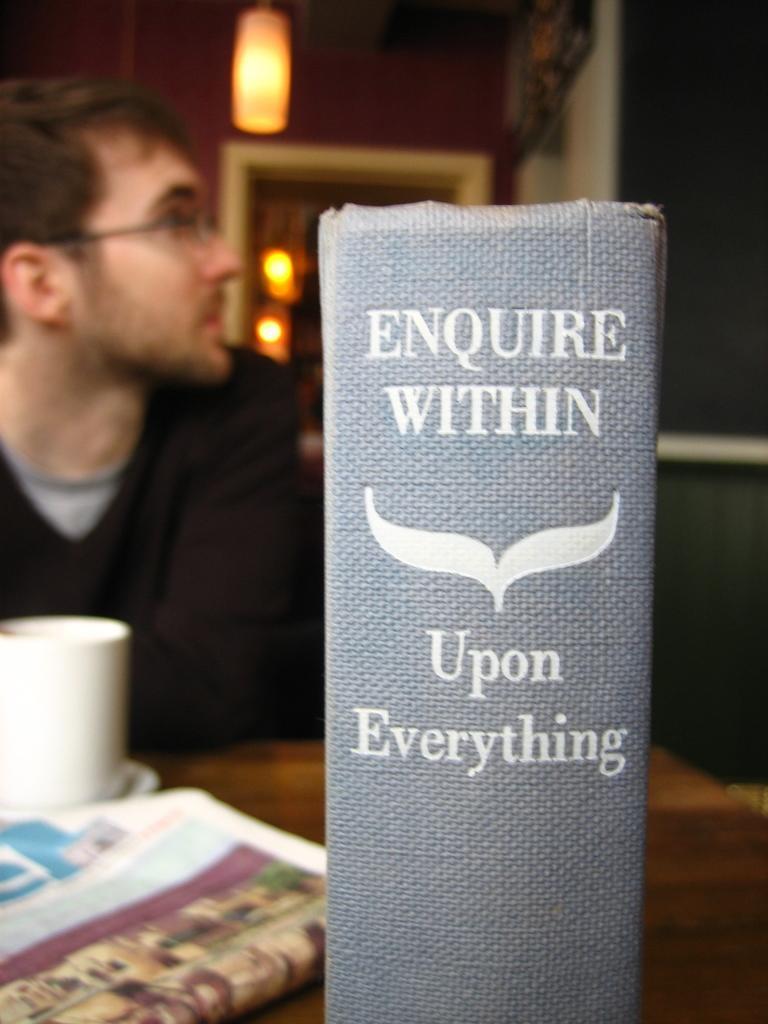Can you describe this image briefly? In this image, we can see a box and there is some text on it. In the background, there is a person wearing glasses and there are lights and we can see a cup and a newspaper on the table. 